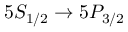<formula> <loc_0><loc_0><loc_500><loc_500>5 S _ { 1 / 2 } \rightarrow 5 P _ { 3 / 2 }</formula> 